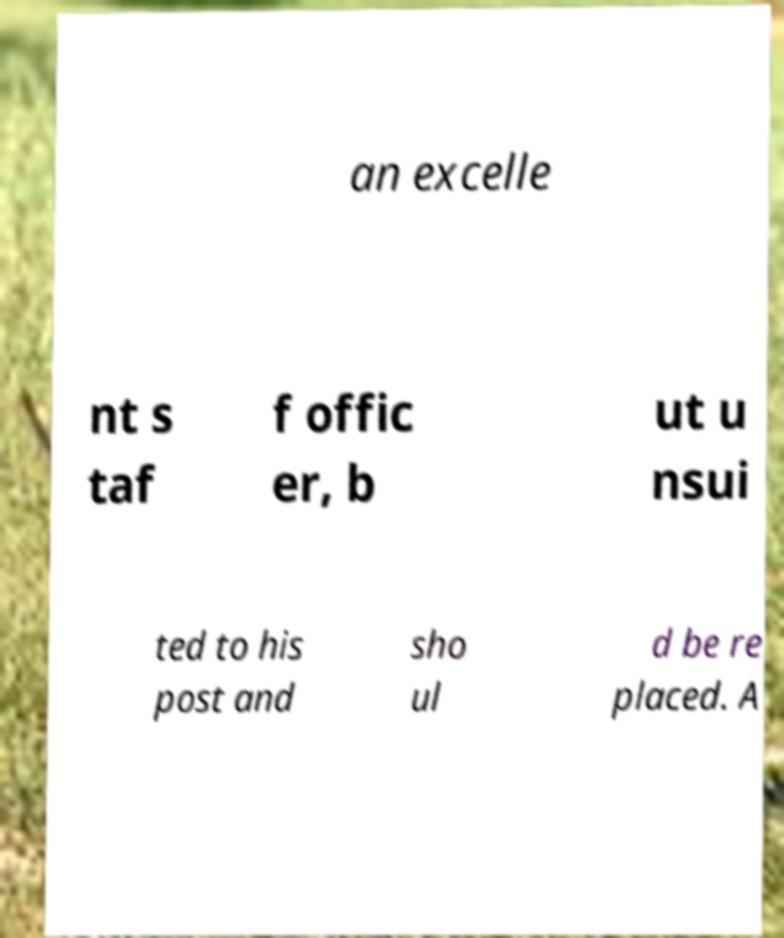Could you assist in decoding the text presented in this image and type it out clearly? an excelle nt s taf f offic er, b ut u nsui ted to his post and sho ul d be re placed. A 